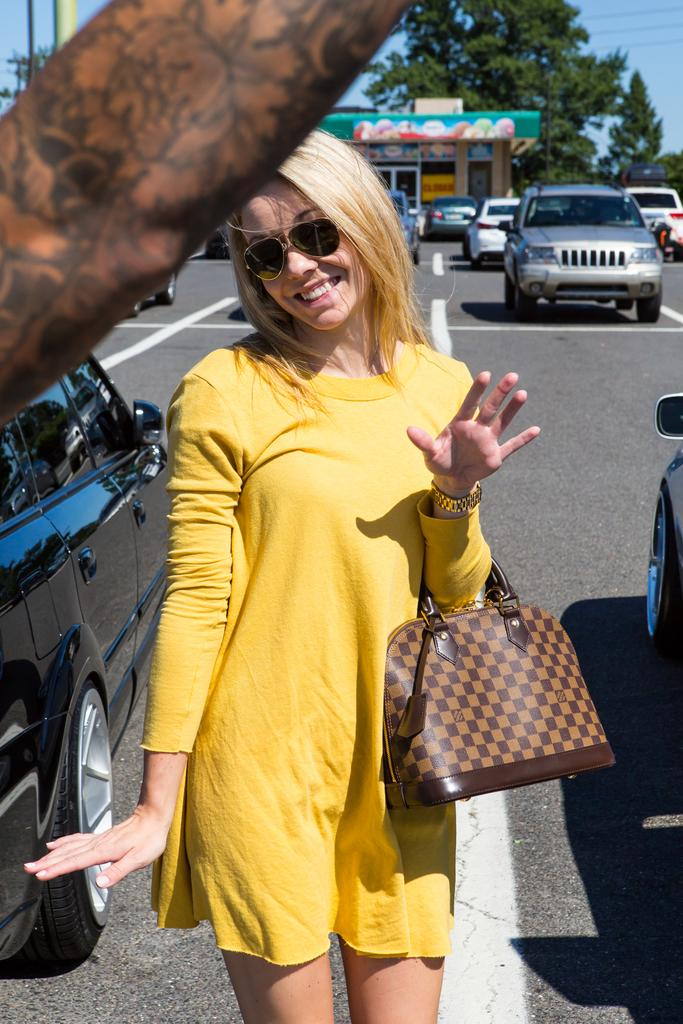Who is present in the image? There is a woman in the image. What is the woman holding in the image? The woman is holding a handbag. What is the woman's expression in the image? The woman is standing and smiling in the image. What can be seen in the background of the image? There are cars, a shop, a tree, wires, and a pole in the background of the image. What is the color of the sky in the image? The sky is blue in color. What type of rake is being used to clean the sidewalk in the image? There is no rake present in the image; it features a woman holding a handbag and various elements in the background. 